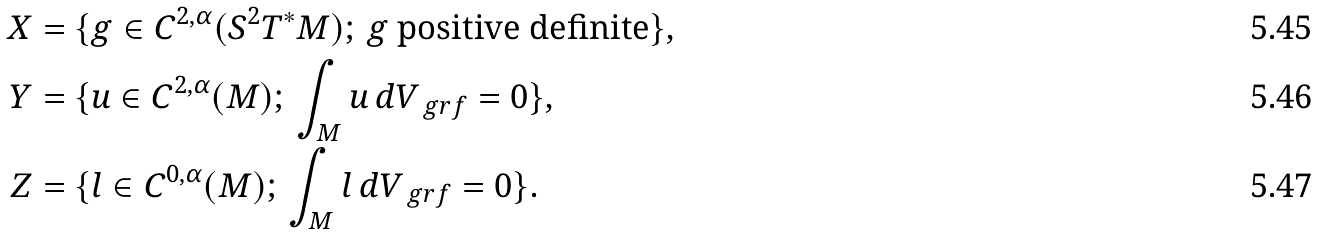<formula> <loc_0><loc_0><loc_500><loc_500>X & = \{ g \in C ^ { 2 , \alpha } ( S ^ { 2 } T ^ { \ast } M ) ; \, g \text { positive definite} \} , \\ Y & = \{ u \in C ^ { 2 , \alpha } ( M ) ; \, \int _ { M } u \, d V _ { \ g r f } = 0 \} , \\ Z & = \{ l \in C ^ { 0 , \alpha } ( M ) ; \, \int _ { M } l \, d V _ { \ g r f } = 0 \} .</formula> 